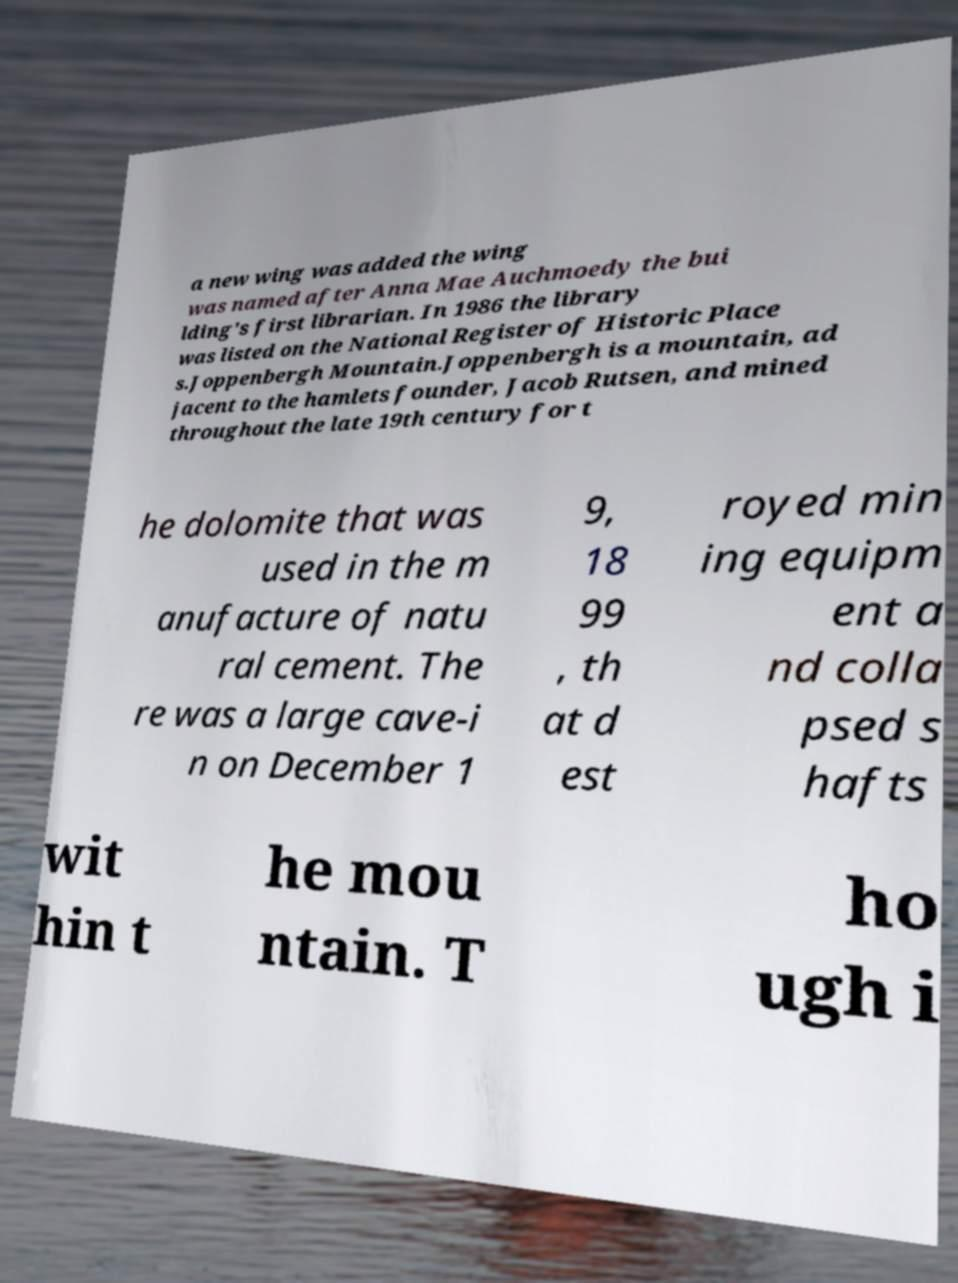Can you read and provide the text displayed in the image?This photo seems to have some interesting text. Can you extract and type it out for me? a new wing was added the wing was named after Anna Mae Auchmoedy the bui lding's first librarian. In 1986 the library was listed on the National Register of Historic Place s.Joppenbergh Mountain.Joppenbergh is a mountain, ad jacent to the hamlets founder, Jacob Rutsen, and mined throughout the late 19th century for t he dolomite that was used in the m anufacture of natu ral cement. The re was a large cave-i n on December 1 9, 18 99 , th at d est royed min ing equipm ent a nd colla psed s hafts wit hin t he mou ntain. T ho ugh i 